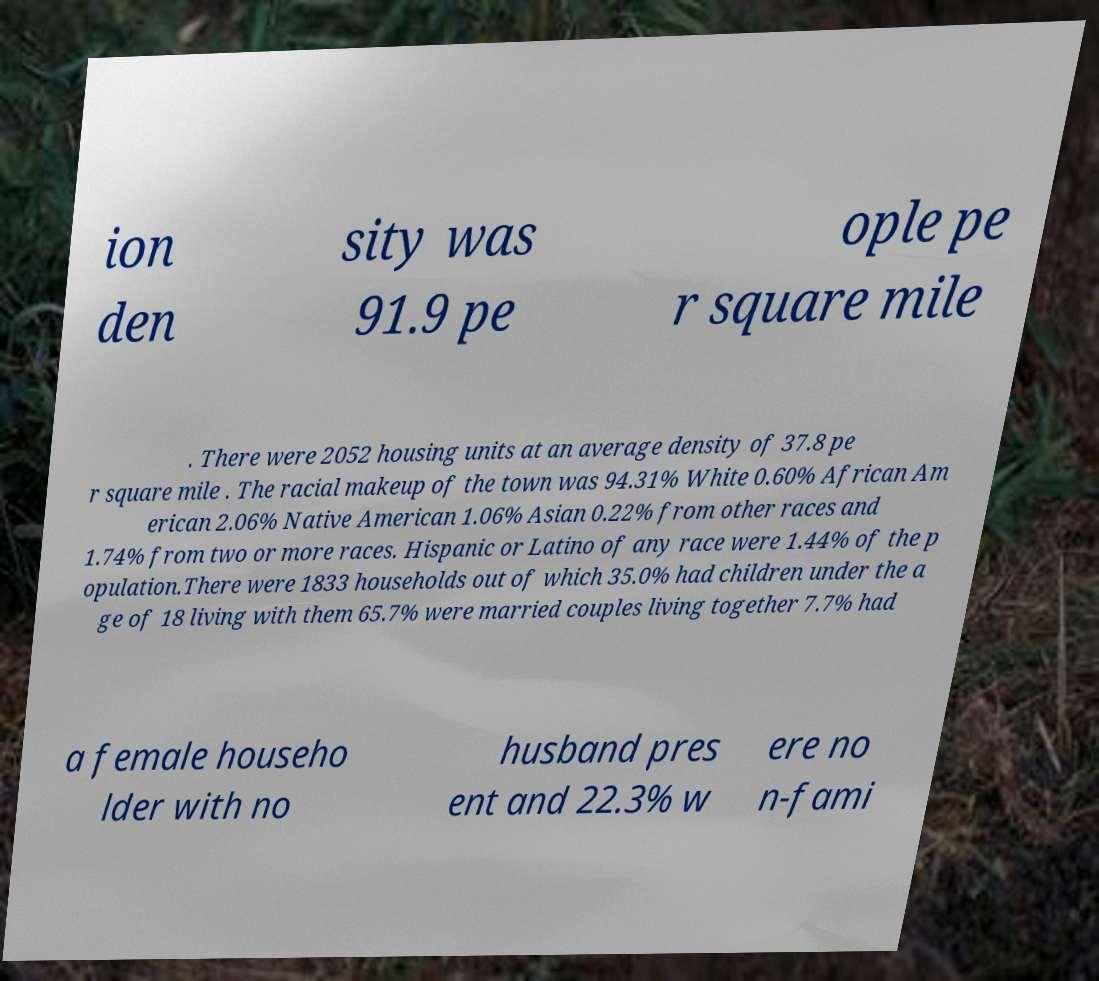There's text embedded in this image that I need extracted. Can you transcribe it verbatim? ion den sity was 91.9 pe ople pe r square mile . There were 2052 housing units at an average density of 37.8 pe r square mile . The racial makeup of the town was 94.31% White 0.60% African Am erican 2.06% Native American 1.06% Asian 0.22% from other races and 1.74% from two or more races. Hispanic or Latino of any race were 1.44% of the p opulation.There were 1833 households out of which 35.0% had children under the a ge of 18 living with them 65.7% were married couples living together 7.7% had a female househo lder with no husband pres ent and 22.3% w ere no n-fami 